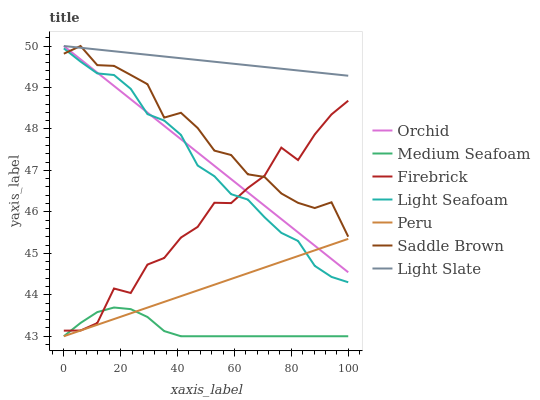Does Medium Seafoam have the minimum area under the curve?
Answer yes or no. Yes. Does Light Slate have the maximum area under the curve?
Answer yes or no. Yes. Does Firebrick have the minimum area under the curve?
Answer yes or no. No. Does Firebrick have the maximum area under the curve?
Answer yes or no. No. Is Light Slate the smoothest?
Answer yes or no. Yes. Is Firebrick the roughest?
Answer yes or no. Yes. Is Medium Seafoam the smoothest?
Answer yes or no. No. Is Medium Seafoam the roughest?
Answer yes or no. No. Does Medium Seafoam have the lowest value?
Answer yes or no. Yes. Does Firebrick have the lowest value?
Answer yes or no. No. Does Orchid have the highest value?
Answer yes or no. Yes. Does Firebrick have the highest value?
Answer yes or no. No. Is Medium Seafoam less than Light Seafoam?
Answer yes or no. Yes. Is Light Seafoam greater than Medium Seafoam?
Answer yes or no. Yes. Does Light Slate intersect Saddle Brown?
Answer yes or no. Yes. Is Light Slate less than Saddle Brown?
Answer yes or no. No. Is Light Slate greater than Saddle Brown?
Answer yes or no. No. Does Medium Seafoam intersect Light Seafoam?
Answer yes or no. No. 